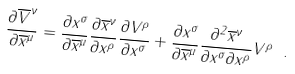<formula> <loc_0><loc_0><loc_500><loc_500>\frac { \partial \overline { V } ^ { \nu } } { \partial \overline { x } ^ { \mu } } = \frac { \partial x ^ { \sigma } } { \partial \overline { x } ^ { \mu } } \frac { \partial \overline { x } ^ { \nu } } { \partial x ^ { \rho } } \frac { \partial V ^ { \rho } } { \partial x ^ { \sigma } } + \frac { \partial x ^ { \sigma } } { \partial \overline { x } ^ { \mu } } \frac { \partial ^ { 2 } \overline { x } ^ { \nu } } { \partial x ^ { \sigma } \partial x ^ { \rho } } V ^ { \rho } \ .</formula> 